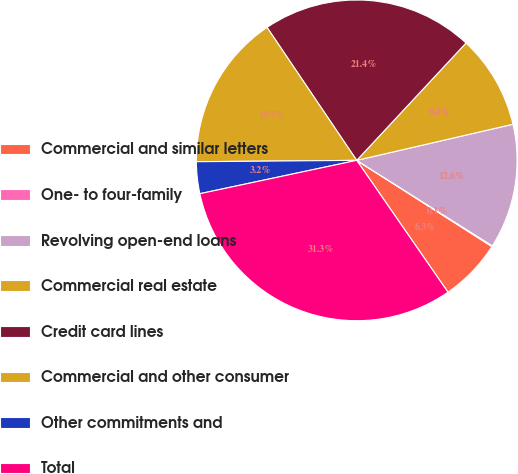Convert chart. <chart><loc_0><loc_0><loc_500><loc_500><pie_chart><fcel>Commercial and similar letters<fcel>One- to four-family<fcel>Revolving open-end loans<fcel>Commercial real estate<fcel>Credit card lines<fcel>Commercial and other consumer<fcel>Other commitments and<fcel>Total<nl><fcel>6.33%<fcel>0.08%<fcel>12.57%<fcel>9.45%<fcel>21.38%<fcel>15.69%<fcel>3.2%<fcel>31.3%<nl></chart> 